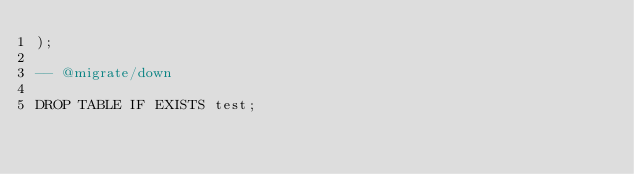Convert code to text. <code><loc_0><loc_0><loc_500><loc_500><_SQL_>);

-- @migrate/down

DROP TABLE IF EXISTS test;
</code> 